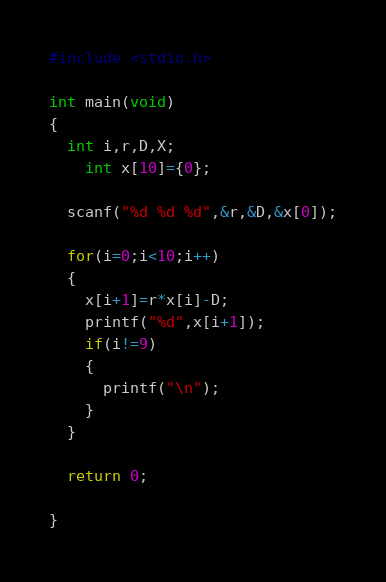<code> <loc_0><loc_0><loc_500><loc_500><_C_>#include <stdio.h>

int main(void)
{
  int i,r,D,X;
    int x[10]={0};
  
  scanf("%d %d %d",&r,&D,&x[0]);
  
  for(i=0;i<10;i++)
  {
    x[i+1]=r*x[i]-D;
    printf("%d",x[i+1]); 
    if(i!=9)
    {
      printf("\n");
    }
  }
  
  return 0;
    
}</code> 